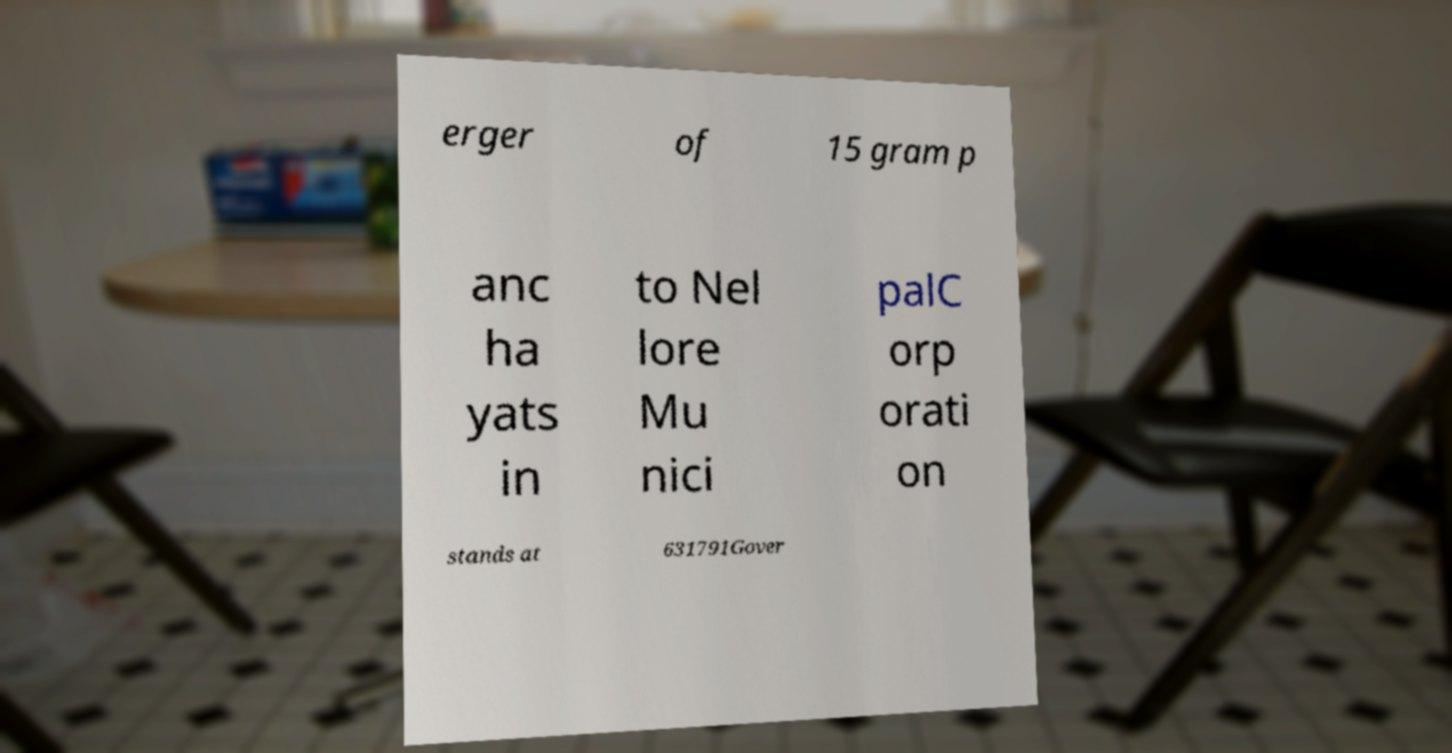Could you extract and type out the text from this image? erger of 15 gram p anc ha yats in to Nel lore Mu nici palC orp orati on stands at 631791Gover 